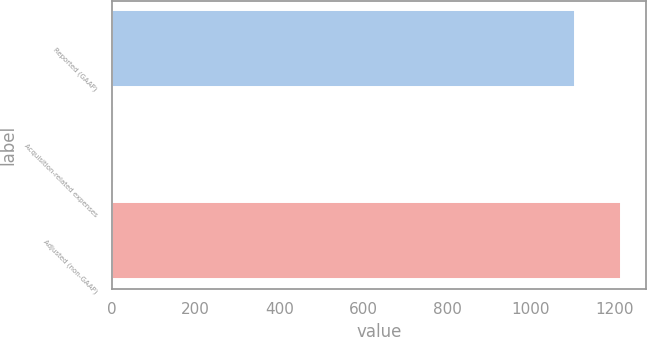<chart> <loc_0><loc_0><loc_500><loc_500><bar_chart><fcel>Reported (GAAP)<fcel>Acquisition-related expenses<fcel>Adjusted (non-GAAP)<nl><fcel>1104.7<fcel>5.7<fcel>1215.17<nl></chart> 